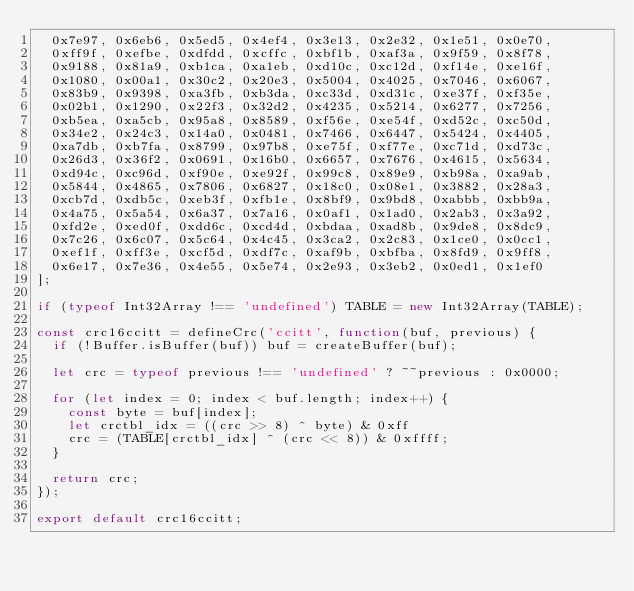<code> <loc_0><loc_0><loc_500><loc_500><_JavaScript_>  0x7e97, 0x6eb6, 0x5ed5, 0x4ef4, 0x3e13, 0x2e32, 0x1e51, 0x0e70,
  0xff9f, 0xefbe, 0xdfdd, 0xcffc, 0xbf1b, 0xaf3a, 0x9f59, 0x8f78,
  0x9188, 0x81a9, 0xb1ca, 0xa1eb, 0xd10c, 0xc12d, 0xf14e, 0xe16f,
  0x1080, 0x00a1, 0x30c2, 0x20e3, 0x5004, 0x4025, 0x7046, 0x6067,
  0x83b9, 0x9398, 0xa3fb, 0xb3da, 0xc33d, 0xd31c, 0xe37f, 0xf35e,
  0x02b1, 0x1290, 0x22f3, 0x32d2, 0x4235, 0x5214, 0x6277, 0x7256,
  0xb5ea, 0xa5cb, 0x95a8, 0x8589, 0xf56e, 0xe54f, 0xd52c, 0xc50d,
  0x34e2, 0x24c3, 0x14a0, 0x0481, 0x7466, 0x6447, 0x5424, 0x4405,
  0xa7db, 0xb7fa, 0x8799, 0x97b8, 0xe75f, 0xf77e, 0xc71d, 0xd73c,
  0x26d3, 0x36f2, 0x0691, 0x16b0, 0x6657, 0x7676, 0x4615, 0x5634,
  0xd94c, 0xc96d, 0xf90e, 0xe92f, 0x99c8, 0x89e9, 0xb98a, 0xa9ab,
  0x5844, 0x4865, 0x7806, 0x6827, 0x18c0, 0x08e1, 0x3882, 0x28a3,
  0xcb7d, 0xdb5c, 0xeb3f, 0xfb1e, 0x8bf9, 0x9bd8, 0xabbb, 0xbb9a,
  0x4a75, 0x5a54, 0x6a37, 0x7a16, 0x0af1, 0x1ad0, 0x2ab3, 0x3a92,
  0xfd2e, 0xed0f, 0xdd6c, 0xcd4d, 0xbdaa, 0xad8b, 0x9de8, 0x8dc9,
  0x7c26, 0x6c07, 0x5c64, 0x4c45, 0x3ca2, 0x2c83, 0x1ce0, 0x0cc1,
  0xef1f, 0xff3e, 0xcf5d, 0xdf7c, 0xaf9b, 0xbfba, 0x8fd9, 0x9ff8,
  0x6e17, 0x7e36, 0x4e55, 0x5e74, 0x2e93, 0x3eb2, 0x0ed1, 0x1ef0
];

if (typeof Int32Array !== 'undefined') TABLE = new Int32Array(TABLE);

const crc16ccitt = defineCrc('ccitt', function(buf, previous) {
  if (!Buffer.isBuffer(buf)) buf = createBuffer(buf);

  let crc = typeof previous !== 'undefined' ? ~~previous : 0x0000;

  for (let index = 0; index < buf.length; index++) {
    const byte = buf[index];
    let crctbl_idx = ((crc >> 8) ^ byte) & 0xff
    crc = (TABLE[crctbl_idx] ^ (crc << 8)) & 0xffff;
  }

  return crc;
});

export default crc16ccitt;</code> 